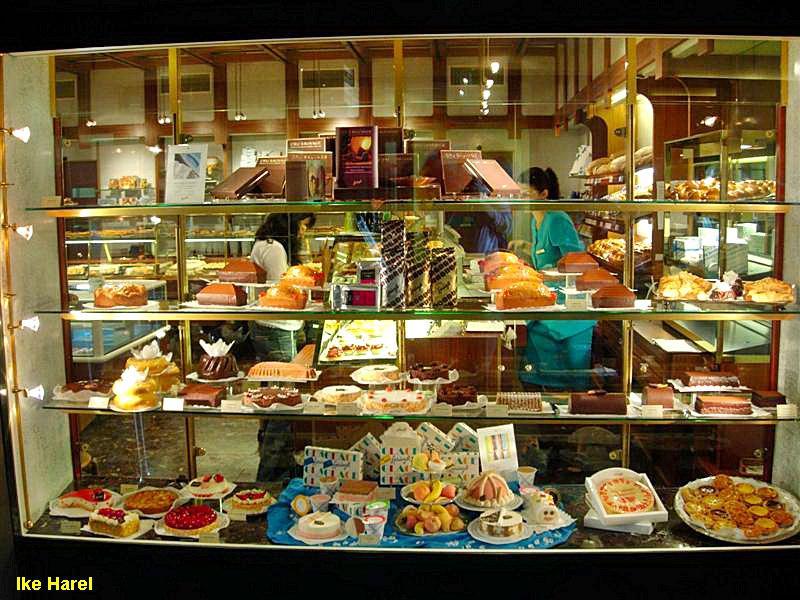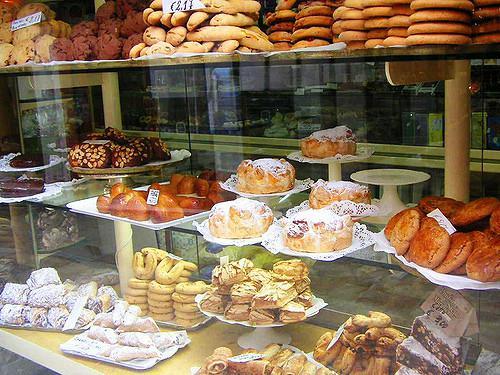The first image is the image on the left, the second image is the image on the right. Considering the images on both sides, is "At least one person is in one image behind a filled bakery display case with three or more shelves and a glass front" valid? Answer yes or no. Yes. 